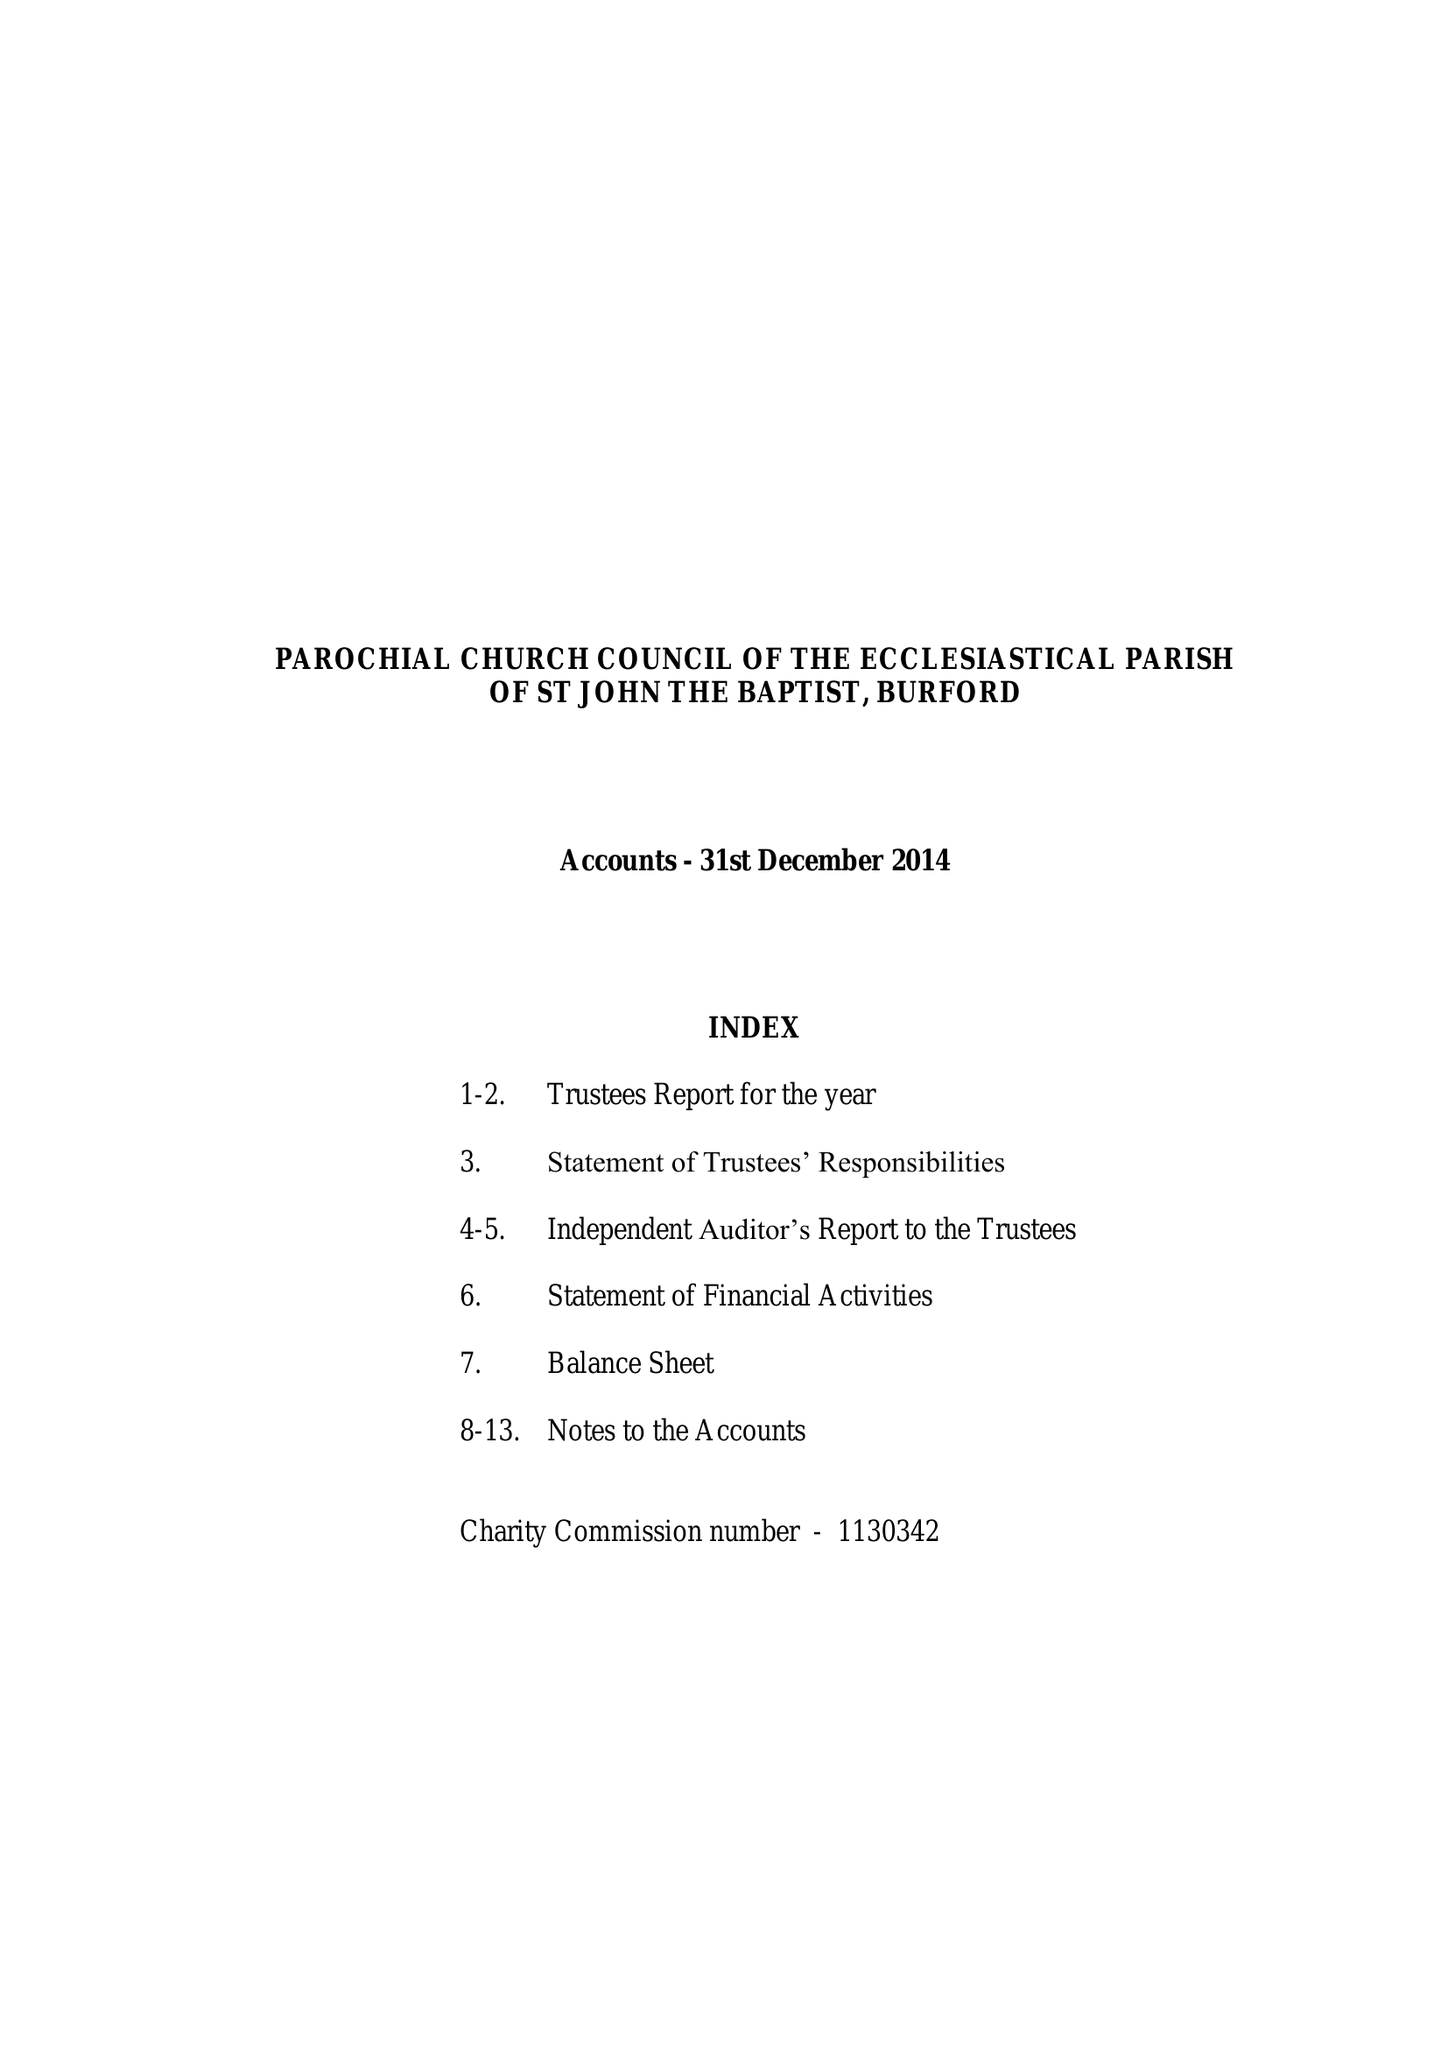What is the value for the report_date?
Answer the question using a single word or phrase. 2014-12-31 